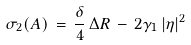Convert formula to latex. <formula><loc_0><loc_0><loc_500><loc_500>\sigma _ { 2 } ( A ) \, = \, \frac { \delta } { 4 } \, \Delta R \, - \, 2 \gamma _ { 1 } \, | \eta | ^ { 2 }</formula> 